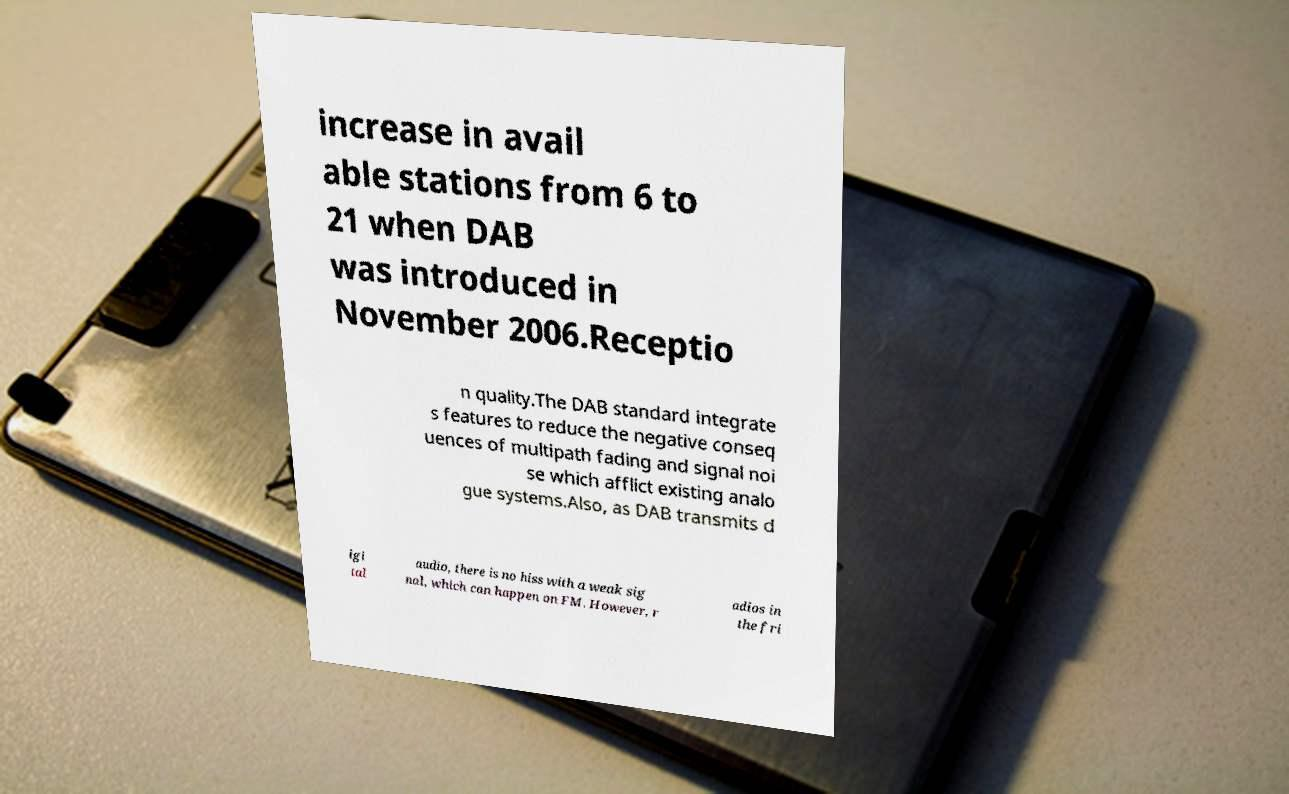Could you assist in decoding the text presented in this image and type it out clearly? increase in avail able stations from 6 to 21 when DAB was introduced in November 2006.Receptio n quality.The DAB standard integrate s features to reduce the negative conseq uences of multipath fading and signal noi se which afflict existing analo gue systems.Also, as DAB transmits d igi tal audio, there is no hiss with a weak sig nal, which can happen on FM. However, r adios in the fri 